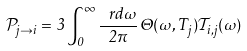<formula> <loc_0><loc_0><loc_500><loc_500>\mathcal { P } _ { j \rightarrow i } = 3 \int _ { 0 } ^ { \infty } \frac { \ r d \omega } { 2 \pi } \, \Theta ( \omega , T _ { j } ) \mathcal { T } _ { i , j } ( \omega )</formula> 